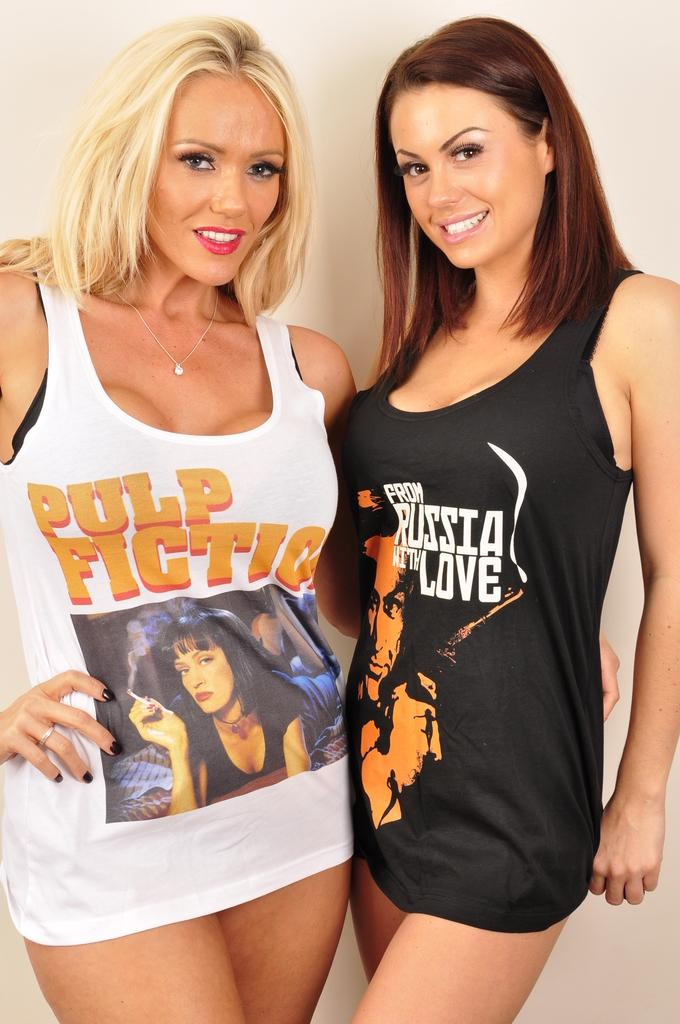<image>
Create a compact narrative representing the image presented. A woman is wearing a Pulp Fiction tanktop with no pants. 